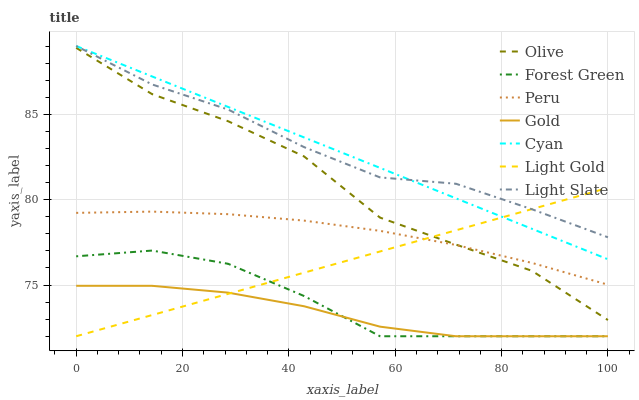Does Gold have the minimum area under the curve?
Answer yes or no. Yes. Does Light Slate have the maximum area under the curve?
Answer yes or no. Yes. Does Forest Green have the minimum area under the curve?
Answer yes or no. No. Does Forest Green have the maximum area under the curve?
Answer yes or no. No. Is Cyan the smoothest?
Answer yes or no. Yes. Is Olive the roughest?
Answer yes or no. Yes. Is Light Slate the smoothest?
Answer yes or no. No. Is Light Slate the roughest?
Answer yes or no. No. Does Gold have the lowest value?
Answer yes or no. Yes. Does Light Slate have the lowest value?
Answer yes or no. No. Does Cyan have the highest value?
Answer yes or no. Yes. Does Forest Green have the highest value?
Answer yes or no. No. Is Peru less than Light Slate?
Answer yes or no. Yes. Is Cyan greater than Forest Green?
Answer yes or no. Yes. Does Gold intersect Light Gold?
Answer yes or no. Yes. Is Gold less than Light Gold?
Answer yes or no. No. Is Gold greater than Light Gold?
Answer yes or no. No. Does Peru intersect Light Slate?
Answer yes or no. No. 